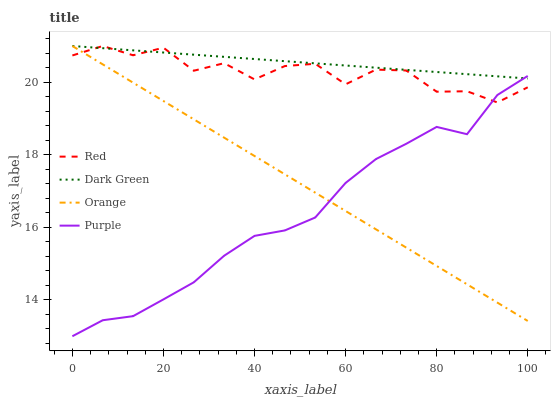Does Purple have the minimum area under the curve?
Answer yes or no. Yes. Does Dark Green have the maximum area under the curve?
Answer yes or no. Yes. Does Red have the minimum area under the curve?
Answer yes or no. No. Does Red have the maximum area under the curve?
Answer yes or no. No. Is Orange the smoothest?
Answer yes or no. Yes. Is Red the roughest?
Answer yes or no. Yes. Is Purple the smoothest?
Answer yes or no. No. Is Purple the roughest?
Answer yes or no. No. Does Purple have the lowest value?
Answer yes or no. Yes. Does Red have the lowest value?
Answer yes or no. No. Does Dark Green have the highest value?
Answer yes or no. Yes. Does Purple have the highest value?
Answer yes or no. No. Does Purple intersect Red?
Answer yes or no. Yes. Is Purple less than Red?
Answer yes or no. No. Is Purple greater than Red?
Answer yes or no. No. 